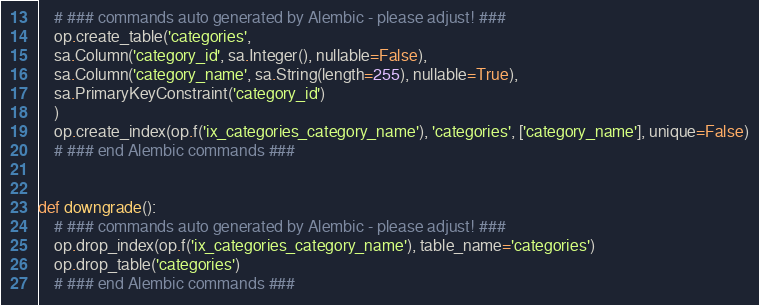<code> <loc_0><loc_0><loc_500><loc_500><_Python_>    # ### commands auto generated by Alembic - please adjust! ###
    op.create_table('categories',
    sa.Column('category_id', sa.Integer(), nullable=False),
    sa.Column('category_name', sa.String(length=255), nullable=True),
    sa.PrimaryKeyConstraint('category_id')
    )
    op.create_index(op.f('ix_categories_category_name'), 'categories', ['category_name'], unique=False)
    # ### end Alembic commands ###


def downgrade():
    # ### commands auto generated by Alembic - please adjust! ###
    op.drop_index(op.f('ix_categories_category_name'), table_name='categories')
    op.drop_table('categories')
    # ### end Alembic commands ###
</code> 